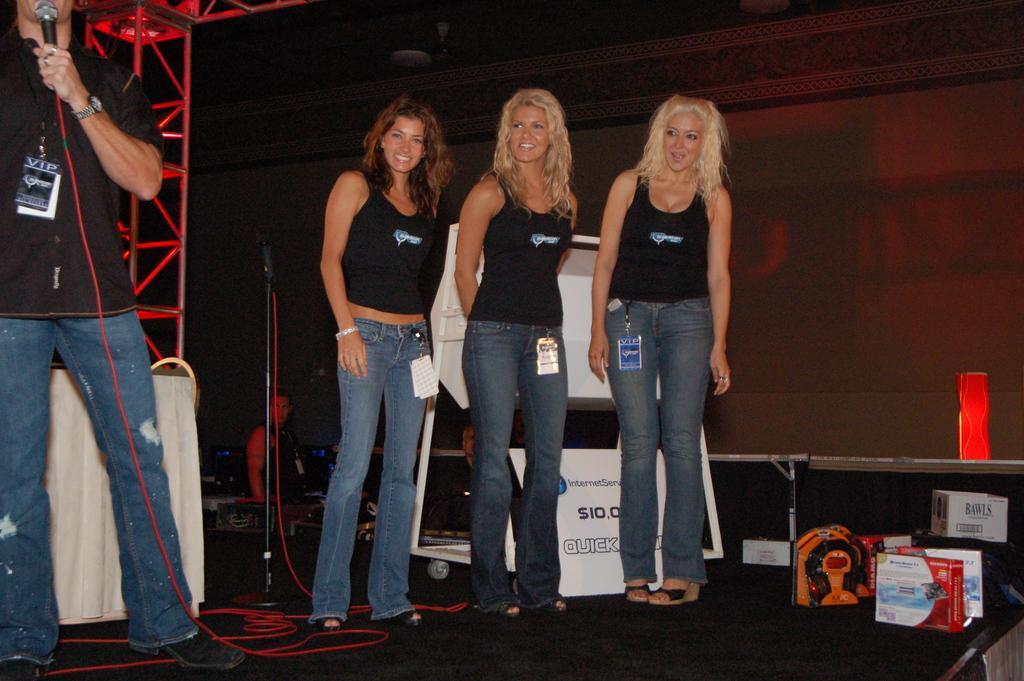Can you describe this image briefly? In this picture we can observe three women standing on the floor. All of them were wearing black color T shirts and smiling. On the left side we can observe a man, holding a mic in his hand. We can observe a red color wire and a stand here. In the background there is a wall. On the right side we can observe boxes placed on the floor. 